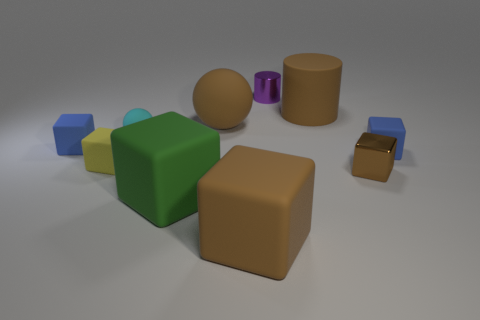Subtract 2 cubes. How many cubes are left? 4 Subtract all brown blocks. How many blocks are left? 4 Subtract all blue cubes. How many cubes are left? 4 Subtract all cyan cubes. Subtract all gray balls. How many cubes are left? 6 Subtract all balls. How many objects are left? 8 Subtract all matte cylinders. Subtract all tiny purple things. How many objects are left? 8 Add 5 metallic cylinders. How many metallic cylinders are left? 6 Add 3 small yellow matte cubes. How many small yellow matte cubes exist? 4 Subtract 0 gray cylinders. How many objects are left? 10 